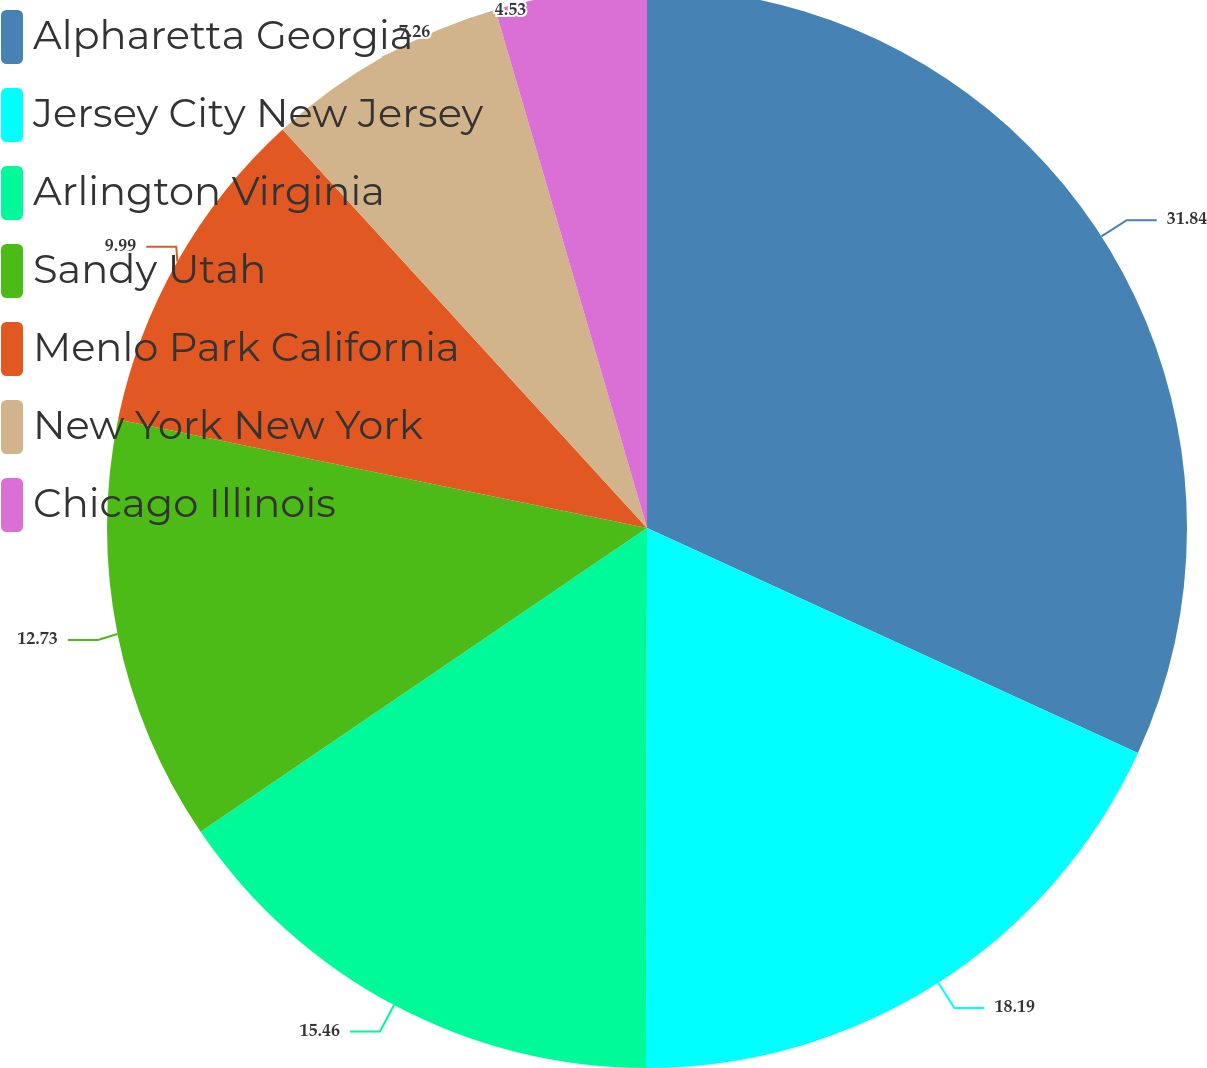Convert chart. <chart><loc_0><loc_0><loc_500><loc_500><pie_chart><fcel>Alpharetta Georgia<fcel>Jersey City New Jersey<fcel>Arlington Virginia<fcel>Sandy Utah<fcel>Menlo Park California<fcel>New York New York<fcel>Chicago Illinois<nl><fcel>31.84%<fcel>18.19%<fcel>15.46%<fcel>12.73%<fcel>9.99%<fcel>7.26%<fcel>4.53%<nl></chart> 